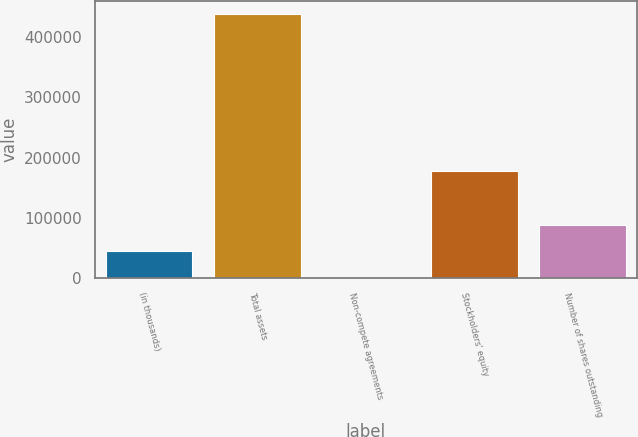<chart> <loc_0><loc_0><loc_500><loc_500><bar_chart><fcel>(in thousands)<fcel>Total assets<fcel>Non-compete agreements<fcel>Stockholders' equity<fcel>Number of shares outstanding<nl><fcel>44252.4<fcel>438420<fcel>456<fcel>176951<fcel>88048.8<nl></chart> 